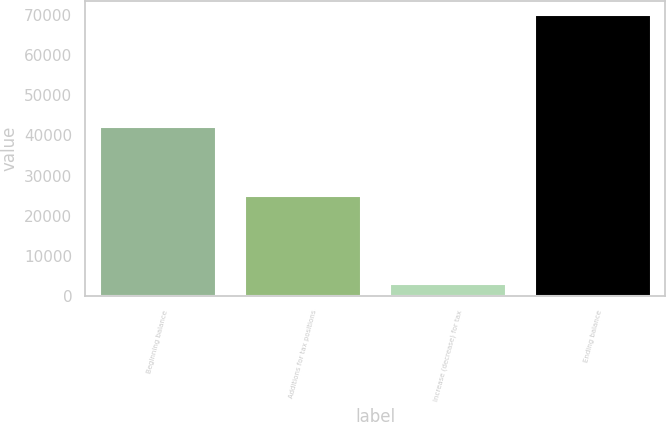<chart> <loc_0><loc_0><loc_500><loc_500><bar_chart><fcel>Beginning balance<fcel>Additions for tax positions<fcel>Increase (decrease) for tax<fcel>Ending balance<nl><fcel>42011<fcel>24905<fcel>3083<fcel>69999<nl></chart> 